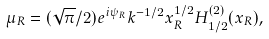<formula> <loc_0><loc_0><loc_500><loc_500>\mu _ { R } = ( \sqrt { \pi } / 2 ) e ^ { i \psi _ { R } } k ^ { - 1 / 2 } x _ { R } ^ { 1 / 2 } H _ { 1 / 2 } ^ { ( 2 ) } ( x _ { R } ) ,</formula> 